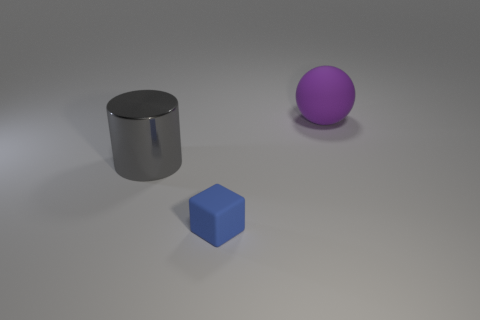Is there any other thing that is the same size as the blue object?
Make the answer very short. No. Is there anything else that has the same material as the big gray cylinder?
Provide a short and direct response. No. Are any red metallic blocks visible?
Make the answer very short. No. The big object on the left side of the large thing that is to the right of the matte thing that is in front of the purple object is what color?
Offer a very short reply. Gray. Are there an equal number of matte objects that are left of the cylinder and tiny blocks that are to the left of the large rubber ball?
Provide a succinct answer. No. There is a object that is the same size as the matte ball; what shape is it?
Make the answer very short. Cylinder. Is there a ball of the same color as the small thing?
Provide a short and direct response. No. What shape is the rubber thing behind the blue block?
Ensure brevity in your answer.  Sphere. What is the color of the large cylinder?
Give a very brief answer. Gray. There is a large thing that is the same material as the cube; what is its color?
Make the answer very short. Purple. 